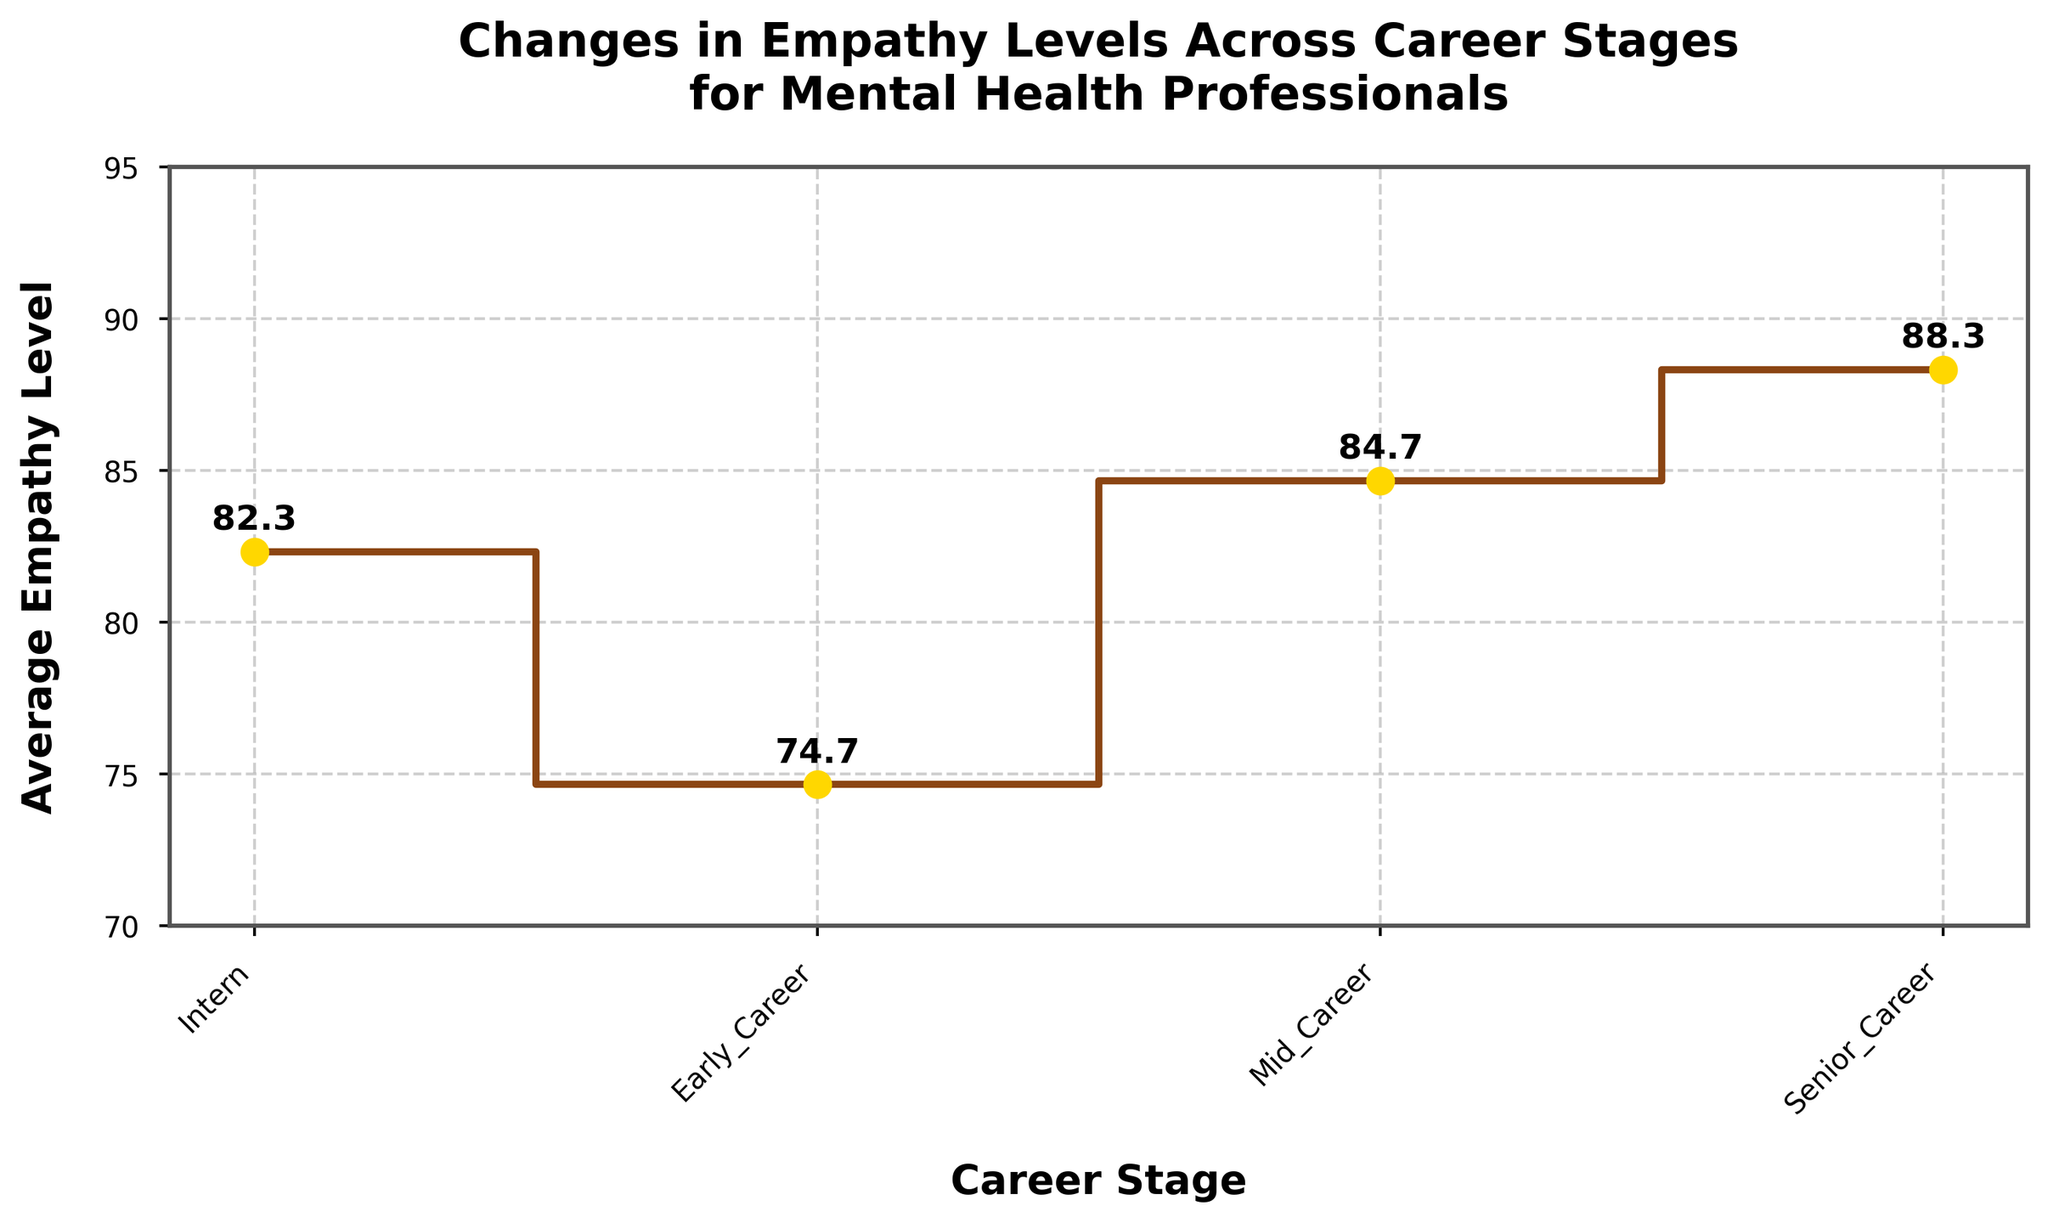What is the title of the figure? The title of the figure is prominently displayed at the top. It reads "Changes in Empathy Levels Across Career Stages for Mental Health Professionals".
Answer: Changes in Empathy Levels Across Career Stages for Mental Health Professionals What is the average empathy level for Mid Career professionals? The average empathy level for Mid Career professionals is shown by the point on the "Mid Career" step of the stair plot. The text label next to the point indicates the value.
Answer: 84.67 How does the empathy level change from Early Career to Mid Career? By observing the steps on the stair plot, we see that the average empathy level for Early Career is shown, and then the point for Mid Career is slightly higher. This indicates an increase.
Answer: Increase Which career stage has the highest average empathy level? By comparing the labeled points on the stair plot, the highest average empathy level is the one located at the topmost point.
Answer: Senior Career Are the empathy levels for Interns increasing, decreasing, or fluctuating across different career stages? Empathy levels initially increase from Intern to Early Career, then continue to rise moderately through Mid Career and Senior Career stages.
Answer: Increasing What is the difference in average empathy level between Intern and Senior Career professionals? The average empathy level for Interns is at 74.67 and for Senior Career is 88.33. The difference is calculated as 88.33 - 74.67.
Answer: 13.66 What are the empathy levels for each career stage displayed in the stair plots? The empathy levels for each career stage are given by the midpoint values in the step plot. The values are:
- Intern: 74.67
- Early Career: 82.33
- Mid Career: 84.67
- Senior Career: 88.33
Answer: Intern: 74.67, Early Career: 82.33, Mid Career: 84.67, Senior Career: 88.33 Does the empathy level steadily increase at each career stage or are there any decreases? The plot shows a steady increase in empathy levels at each career stage without any decreases.
Answer: Steady increase What is the approximate range of average empathy levels shown on the y-axis? The y-axis ranges from 70 to 95, as indicated by the labels along the axis.
Answer: 70 to 95 